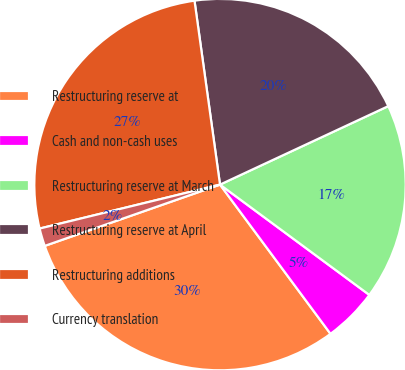<chart> <loc_0><loc_0><loc_500><loc_500><pie_chart><fcel>Restructuring reserve at<fcel>Cash and non-cash uses<fcel>Restructuring reserve at March<fcel>Restructuring reserve at April<fcel>Restructuring additions<fcel>Currency translation<nl><fcel>29.79%<fcel>4.73%<fcel>17.07%<fcel>20.25%<fcel>26.61%<fcel>1.55%<nl></chart> 